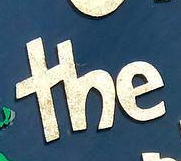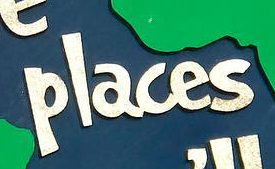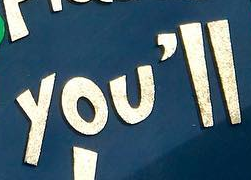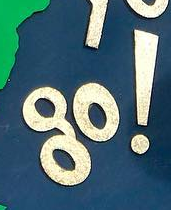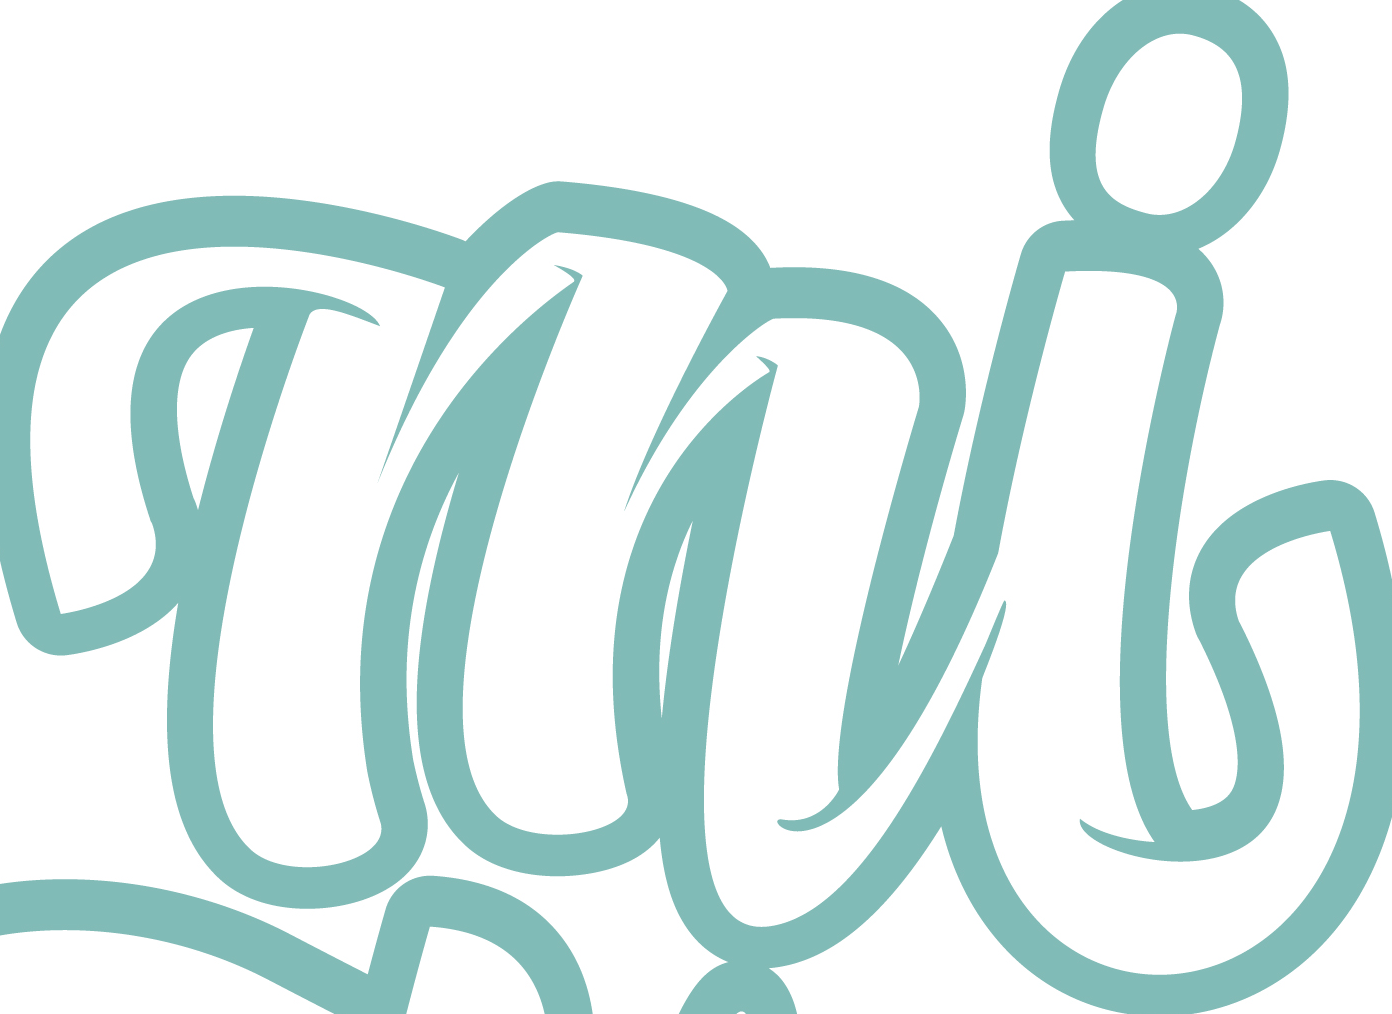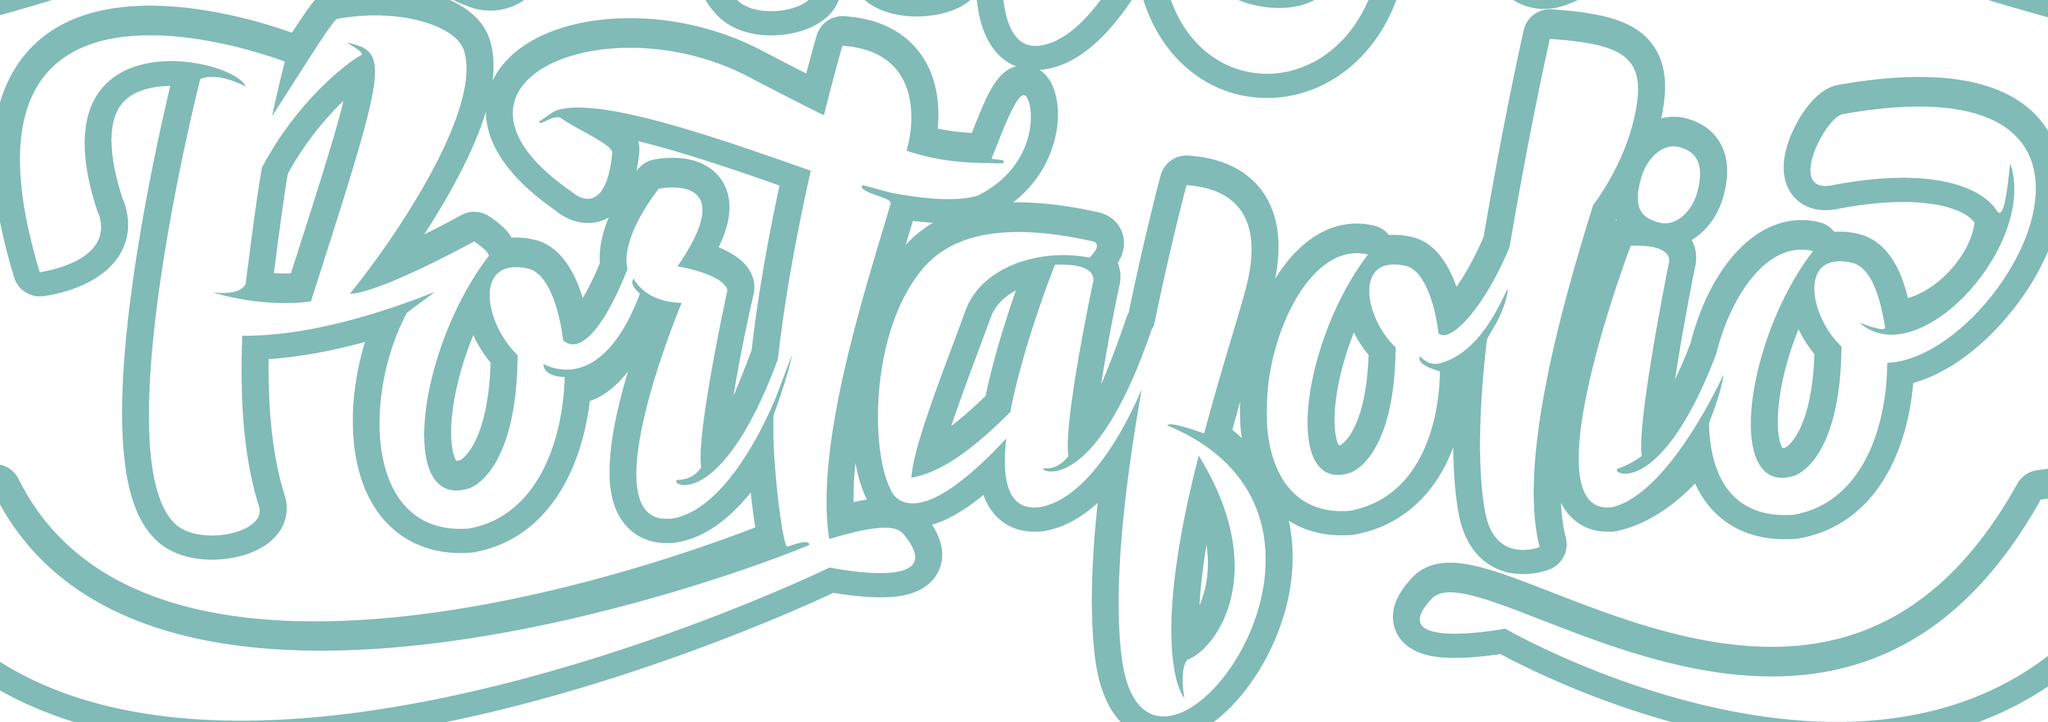What text is displayed in these images sequentially, separated by a semicolon? the; places; you'll; go!; mi; portalolio 